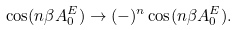Convert formula to latex. <formula><loc_0><loc_0><loc_500><loc_500>\cos ( n \beta A ^ { E } _ { 0 } ) \to ( - ) ^ { n } \cos ( n \beta A ^ { E } _ { 0 } ) .</formula> 